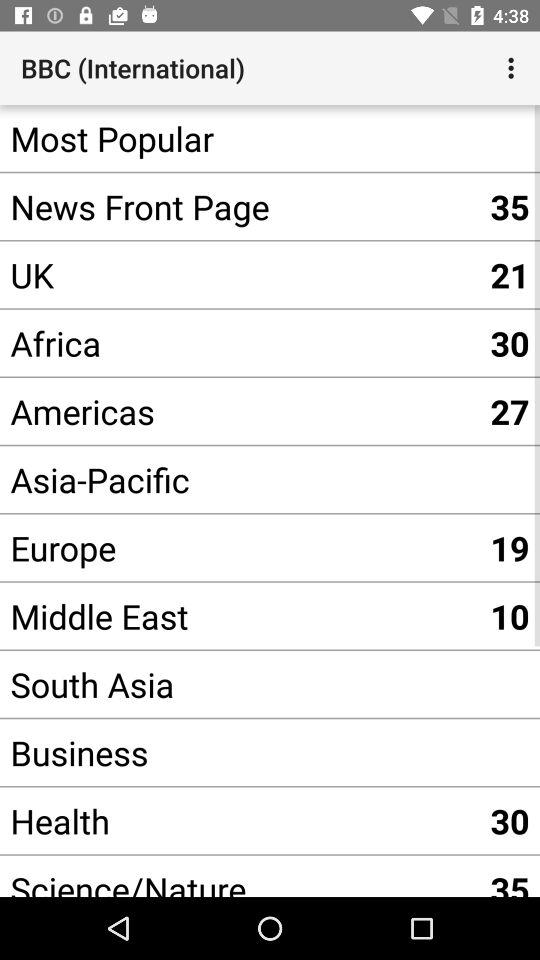What is the number shown for the UK? The shown number is 21. 